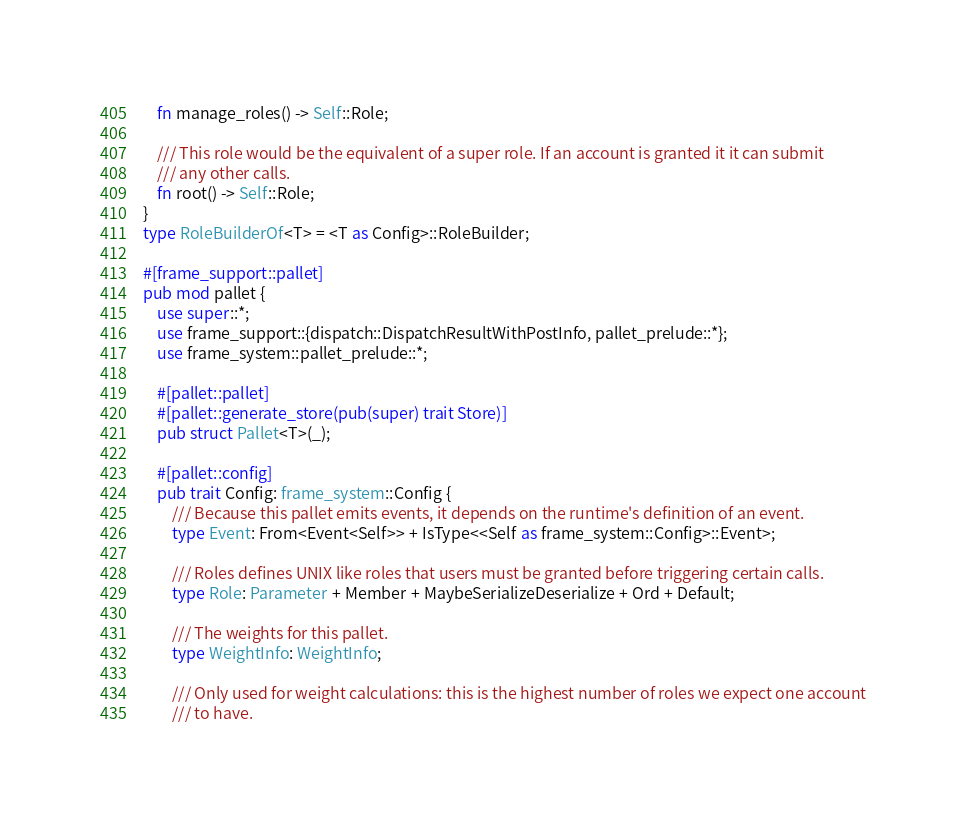<code> <loc_0><loc_0><loc_500><loc_500><_Rust_>    fn manage_roles() -> Self::Role;

    /// This role would be the equivalent of a super role. If an account is granted it it can submit
    /// any other calls.
    fn root() -> Self::Role;
}
type RoleBuilderOf<T> = <T as Config>::RoleBuilder;

#[frame_support::pallet]
pub mod pallet {
    use super::*;
    use frame_support::{dispatch::DispatchResultWithPostInfo, pallet_prelude::*};
    use frame_system::pallet_prelude::*;

    #[pallet::pallet]
    #[pallet::generate_store(pub(super) trait Store)]
    pub struct Pallet<T>(_);

    #[pallet::config]
    pub trait Config: frame_system::Config {
        /// Because this pallet emits events, it depends on the runtime's definition of an event.
        type Event: From<Event<Self>> + IsType<<Self as frame_system::Config>::Event>;

        /// Roles defines UNIX like roles that users must be granted before triggering certain calls.
        type Role: Parameter + Member + MaybeSerializeDeserialize + Ord + Default;

        /// The weights for this pallet.
        type WeightInfo: WeightInfo;

        /// Only used for weight calculations: this is the highest number of roles we expect one account
        /// to have.</code> 